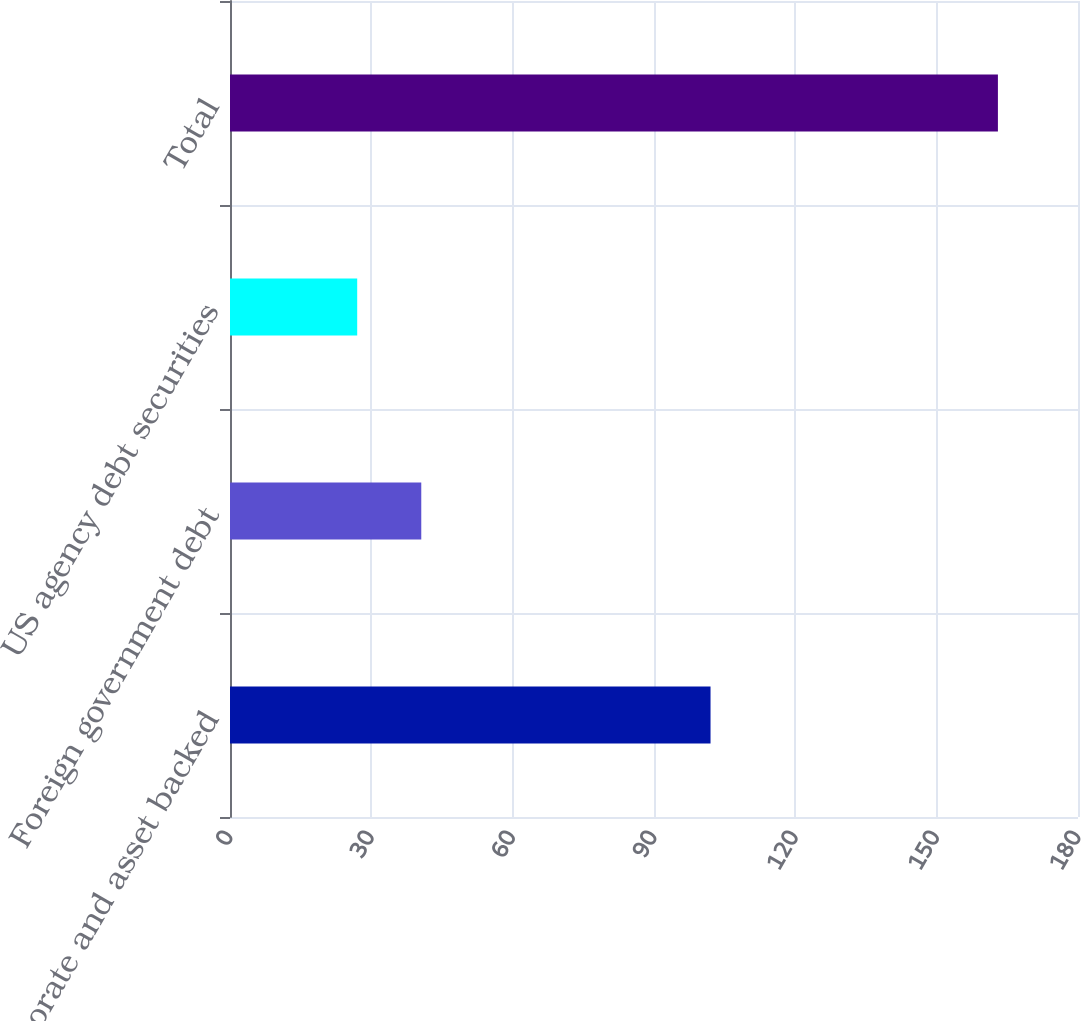Convert chart to OTSL. <chart><loc_0><loc_0><loc_500><loc_500><bar_chart><fcel>Corporate and asset backed<fcel>Foreign government debt<fcel>US agency debt securities<fcel>Total<nl><fcel>102<fcel>40.6<fcel>27<fcel>163<nl></chart> 